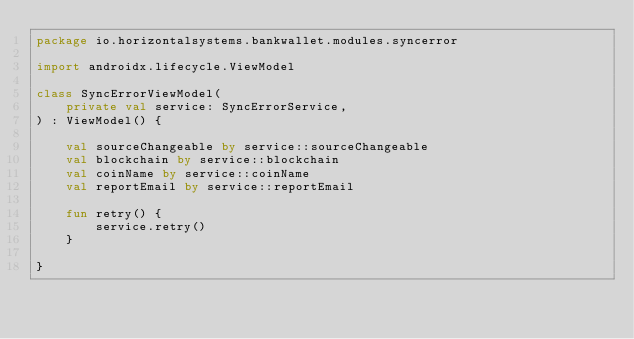<code> <loc_0><loc_0><loc_500><loc_500><_Kotlin_>package io.horizontalsystems.bankwallet.modules.syncerror

import androidx.lifecycle.ViewModel

class SyncErrorViewModel(
    private val service: SyncErrorService,
) : ViewModel() {

    val sourceChangeable by service::sourceChangeable
    val blockchain by service::blockchain
    val coinName by service::coinName
    val reportEmail by service::reportEmail

    fun retry() {
        service.retry()
    }

}
</code> 